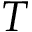<formula> <loc_0><loc_0><loc_500><loc_500>T</formula> 